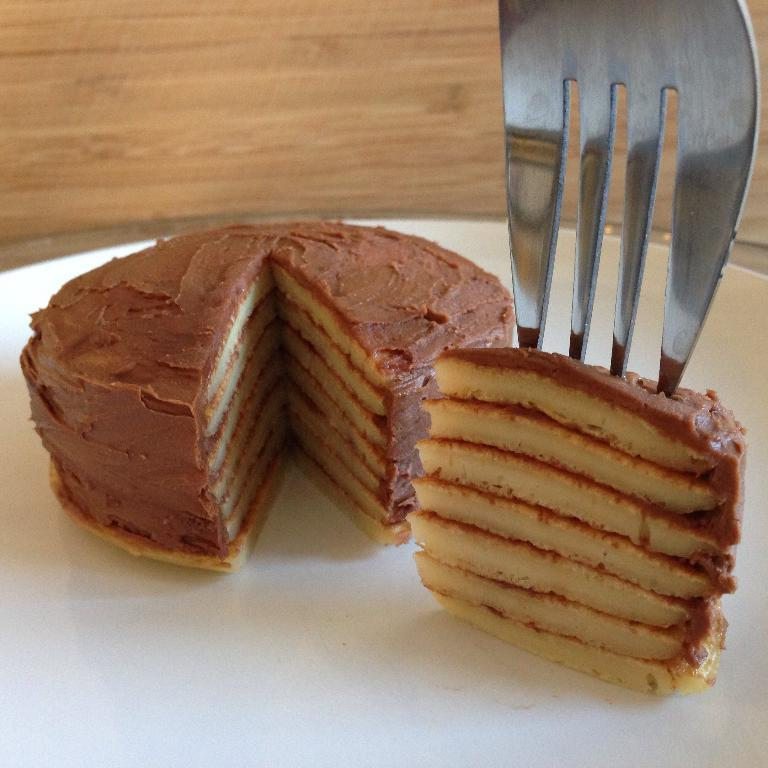What is the main subject of the image? There is a cake in the image. How is the cake being served? A piece of the cake is on a white plate. What utensil is being used to hold the piece of cake? A fork is used to hold the piece of cake. What type of roof can be seen on the cake in the image? There is no roof present on the cake in the image. What type of linen is draped over the cake in the image? There is no linen present in the image; the cake is on a white plate. 